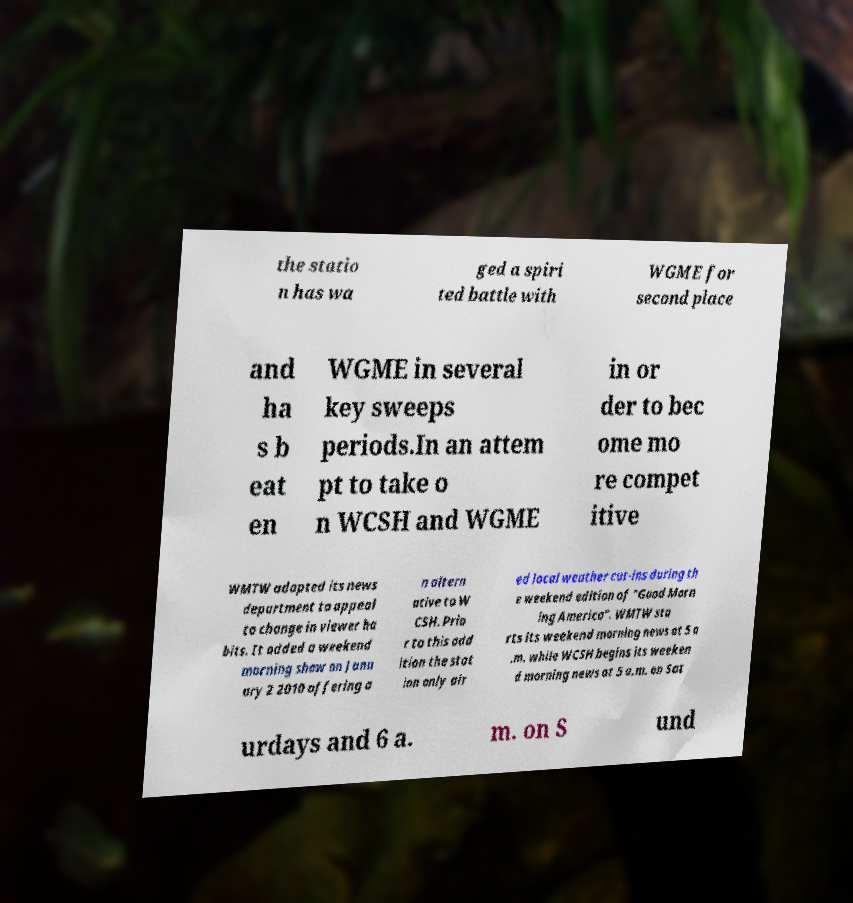There's text embedded in this image that I need extracted. Can you transcribe it verbatim? the statio n has wa ged a spiri ted battle with WGME for second place and ha s b eat en WGME in several key sweeps periods.In an attem pt to take o n WCSH and WGME in or der to bec ome mo re compet itive WMTW adapted its news department to appeal to change in viewer ha bits. It added a weekend morning show on Janu ary 2 2010 offering a n altern ative to W CSH. Prio r to this add ition the stat ion only air ed local weather cut-ins during th e weekend edition of "Good Morn ing America". WMTW sta rts its weekend morning news at 5 a .m. while WCSH begins its weeken d morning news at 5 a.m. on Sat urdays and 6 a. m. on S und 